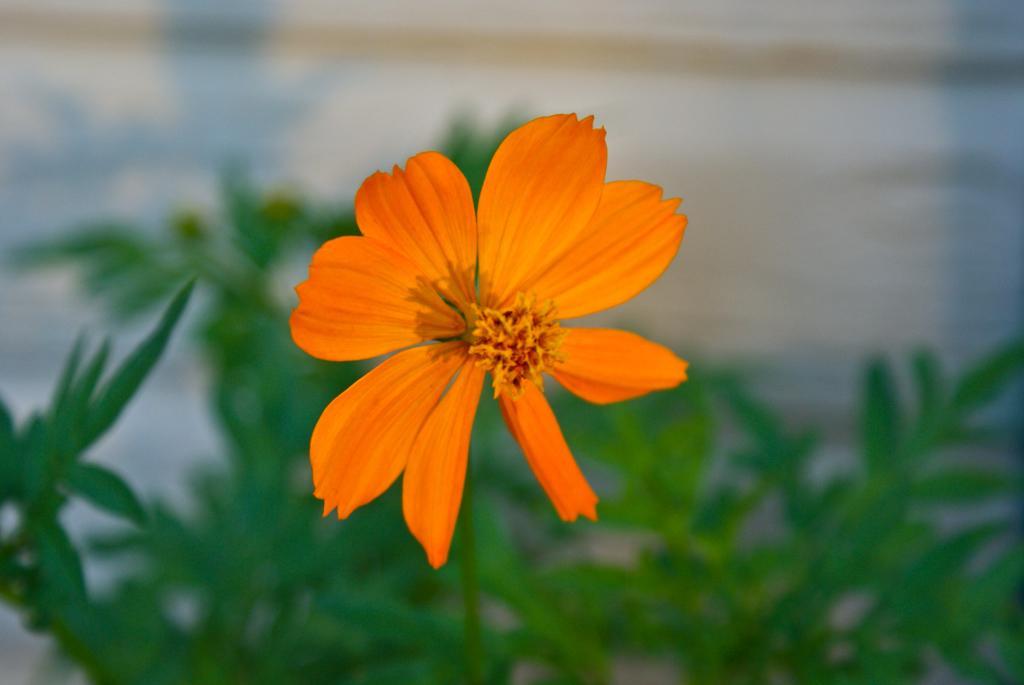Can you describe this image briefly? In the picture I can see a flower plant. The flower is orange in color. The background of the image is blurred. 